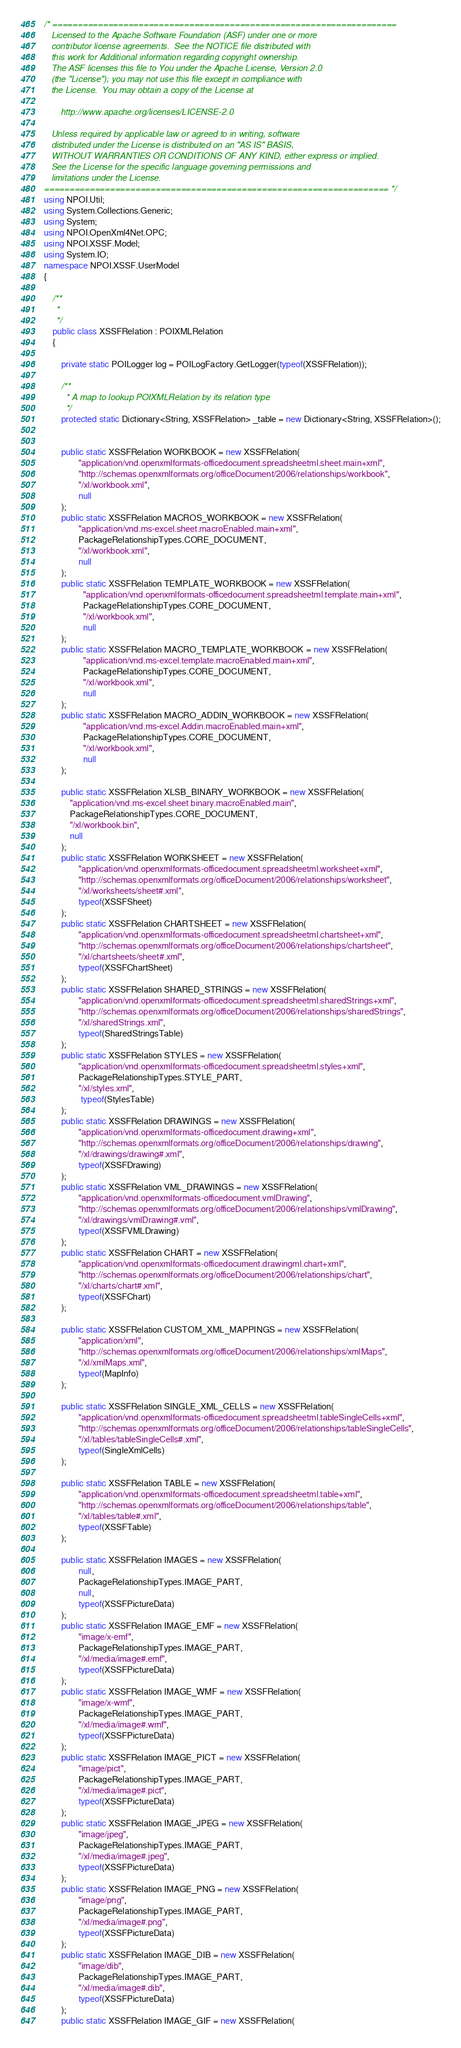<code> <loc_0><loc_0><loc_500><loc_500><_C#_>/* ====================================================================
   Licensed to the Apache Software Foundation (ASF) under one or more
   contributor license agreements.  See the NOTICE file distributed with
   this work for Additional information regarding copyright ownership.
   The ASF licenses this file to You under the Apache License, Version 2.0
   (the "License"); you may not use this file except in compliance with
   the License.  You may obtain a copy of the License at

       http://www.apache.org/licenses/LICENSE-2.0

   Unless required by applicable law or agreed to in writing, software
   distributed under the License is distributed on an "AS IS" BASIS,
   WITHOUT WARRANTIES OR CONDITIONS OF ANY KIND, either express or implied.
   See the License for the specific language governing permissions and
   limitations under the License.
==================================================================== */
using NPOI.Util;
using System.Collections.Generic;
using System;
using NPOI.OpenXml4Net.OPC;
using NPOI.XSSF.Model;
using System.IO;
namespace NPOI.XSSF.UserModel
{

    /**
     *
     */
    public class XSSFRelation : POIXMLRelation
    {

        private static POILogger log = POILogFactory.GetLogger(typeof(XSSFRelation));

        /**
         * A map to lookup POIXMLRelation by its relation type
         */
        protected static Dictionary<String, XSSFRelation> _table = new Dictionary<String, XSSFRelation>();


        public static XSSFRelation WORKBOOK = new XSSFRelation(
                "application/vnd.openxmlformats-officedocument.spreadsheetml.sheet.main+xml",
                "http://schemas.openxmlformats.org/officeDocument/2006/relationships/workbook",
                "/xl/workbook.xml",
                null
        );
        public static XSSFRelation MACROS_WORKBOOK = new XSSFRelation(
                "application/vnd.ms-excel.sheet.macroEnabled.main+xml",
                PackageRelationshipTypes.CORE_DOCUMENT,
                "/xl/workbook.xml",
                null
        );
        public static XSSFRelation TEMPLATE_WORKBOOK = new XSSFRelation(
                  "application/vnd.openxmlformats-officedocument.spreadsheetml.template.main+xml",
                  PackageRelationshipTypes.CORE_DOCUMENT,
                  "/xl/workbook.xml",
                  null
        );
        public static XSSFRelation MACRO_TEMPLATE_WORKBOOK = new XSSFRelation(
                  "application/vnd.ms-excel.template.macroEnabled.main+xml",
                  PackageRelationshipTypes.CORE_DOCUMENT,
                  "/xl/workbook.xml",
                  null
        );
        public static XSSFRelation MACRO_ADDIN_WORKBOOK = new XSSFRelation(
                  "application/vnd.ms-excel.Addin.macroEnabled.main+xml",
                  PackageRelationshipTypes.CORE_DOCUMENT,
                  "/xl/workbook.xml",
                  null
        );

        public static XSSFRelation XLSB_BINARY_WORKBOOK = new XSSFRelation(
            "application/vnd.ms-excel.sheet.binary.macroEnabled.main",
            PackageRelationshipTypes.CORE_DOCUMENT,
            "/xl/workbook.bin",
            null
        );
        public static XSSFRelation WORKSHEET = new XSSFRelation(
                "application/vnd.openxmlformats-officedocument.spreadsheetml.worksheet+xml",
                "http://schemas.openxmlformats.org/officeDocument/2006/relationships/worksheet",
                "/xl/worksheets/sheet#.xml",
                typeof(XSSFSheet)
        );
        public static XSSFRelation CHARTSHEET = new XSSFRelation(
                "application/vnd.openxmlformats-officedocument.spreadsheetml.chartsheet+xml",
                "http://schemas.openxmlformats.org/officeDocument/2006/relationships/chartsheet",
                "/xl/chartsheets/sheet#.xml",
                typeof(XSSFChartSheet)
        );
        public static XSSFRelation SHARED_STRINGS = new XSSFRelation(
                "application/vnd.openxmlformats-officedocument.spreadsheetml.sharedStrings+xml",
                "http://schemas.openxmlformats.org/officeDocument/2006/relationships/sharedStrings",
                "/xl/sharedStrings.xml",
                typeof(SharedStringsTable)
        );
        public static XSSFRelation STYLES = new XSSFRelation(
                "application/vnd.openxmlformats-officedocument.spreadsheetml.styles+xml",
                PackageRelationshipTypes.STYLE_PART,
                "/xl/styles.xml",
                 typeof(StylesTable)
        );
        public static XSSFRelation DRAWINGS = new XSSFRelation(
                "application/vnd.openxmlformats-officedocument.drawing+xml",
                "http://schemas.openxmlformats.org/officeDocument/2006/relationships/drawing",
                "/xl/drawings/drawing#.xml",
                typeof(XSSFDrawing)
        );
        public static XSSFRelation VML_DRAWINGS = new XSSFRelation(
                "application/vnd.openxmlformats-officedocument.vmlDrawing",
                "http://schemas.openxmlformats.org/officeDocument/2006/relationships/vmlDrawing",
                "/xl/drawings/vmlDrawing#.vml",
                typeof(XSSFVMLDrawing)
        );
        public static XSSFRelation CHART = new XSSFRelation(
                "application/vnd.openxmlformats-officedocument.drawingml.chart+xml",
                "http://schemas.openxmlformats.org/officeDocument/2006/relationships/chart",
                "/xl/charts/chart#.xml",
                typeof(XSSFChart)
        );

        public static XSSFRelation CUSTOM_XML_MAPPINGS = new XSSFRelation(
                "application/xml",
                "http://schemas.openxmlformats.org/officeDocument/2006/relationships/xmlMaps",
                "/xl/xmlMaps.xml",
                typeof(MapInfo)
        );

        public static XSSFRelation SINGLE_XML_CELLS = new XSSFRelation(
                "application/vnd.openxmlformats-officedocument.spreadsheetml.tableSingleCells+xml",
                "http://schemas.openxmlformats.org/officeDocument/2006/relationships/tableSingleCells",
                "/xl/tables/tableSingleCells#.xml",
                typeof(SingleXmlCells)
        );

        public static XSSFRelation TABLE = new XSSFRelation(
                "application/vnd.openxmlformats-officedocument.spreadsheetml.table+xml",
                "http://schemas.openxmlformats.org/officeDocument/2006/relationships/table",
                "/xl/tables/table#.xml",
                typeof(XSSFTable)
        );

        public static XSSFRelation IMAGES = new XSSFRelation(
                null,
                PackageRelationshipTypes.IMAGE_PART,
                null,
                typeof(XSSFPictureData)
        );
        public static XSSFRelation IMAGE_EMF = new XSSFRelation(
                "image/x-emf",
                PackageRelationshipTypes.IMAGE_PART,
                "/xl/media/image#.emf",
                typeof(XSSFPictureData)
        );
        public static XSSFRelation IMAGE_WMF = new XSSFRelation(
                "image/x-wmf",
                PackageRelationshipTypes.IMAGE_PART,
                "/xl/media/image#.wmf",
                typeof(XSSFPictureData)
        );
        public static XSSFRelation IMAGE_PICT = new XSSFRelation(
                "image/pict",
                PackageRelationshipTypes.IMAGE_PART,
                "/xl/media/image#.pict",
                typeof(XSSFPictureData)
        );
        public static XSSFRelation IMAGE_JPEG = new XSSFRelation(
                "image/jpeg",
                PackageRelationshipTypes.IMAGE_PART,
                "/xl/media/image#.jpeg",
                typeof(XSSFPictureData)
        );
        public static XSSFRelation IMAGE_PNG = new XSSFRelation(
                "image/png",
                PackageRelationshipTypes.IMAGE_PART,
                "/xl/media/image#.png",
                typeof(XSSFPictureData)
        );
        public static XSSFRelation IMAGE_DIB = new XSSFRelation(
                "image/dib",
                PackageRelationshipTypes.IMAGE_PART,
                "/xl/media/image#.dib",
                typeof(XSSFPictureData)
        );
        public static XSSFRelation IMAGE_GIF = new XSSFRelation(</code> 